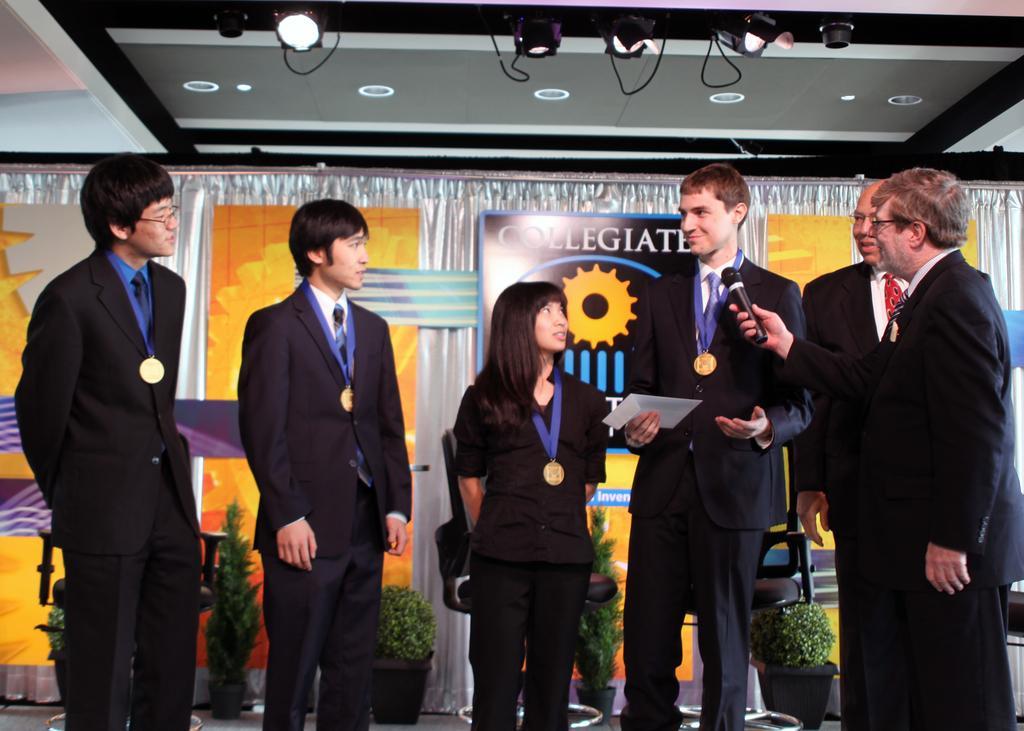How would you summarize this image in a sentence or two? In the image we can see there are people standing and they are wearing formal suit. There are 4 people wearing medals in their neck. Behind there are curtains and there are banners on the curtain. There are plants kept on the pot. 